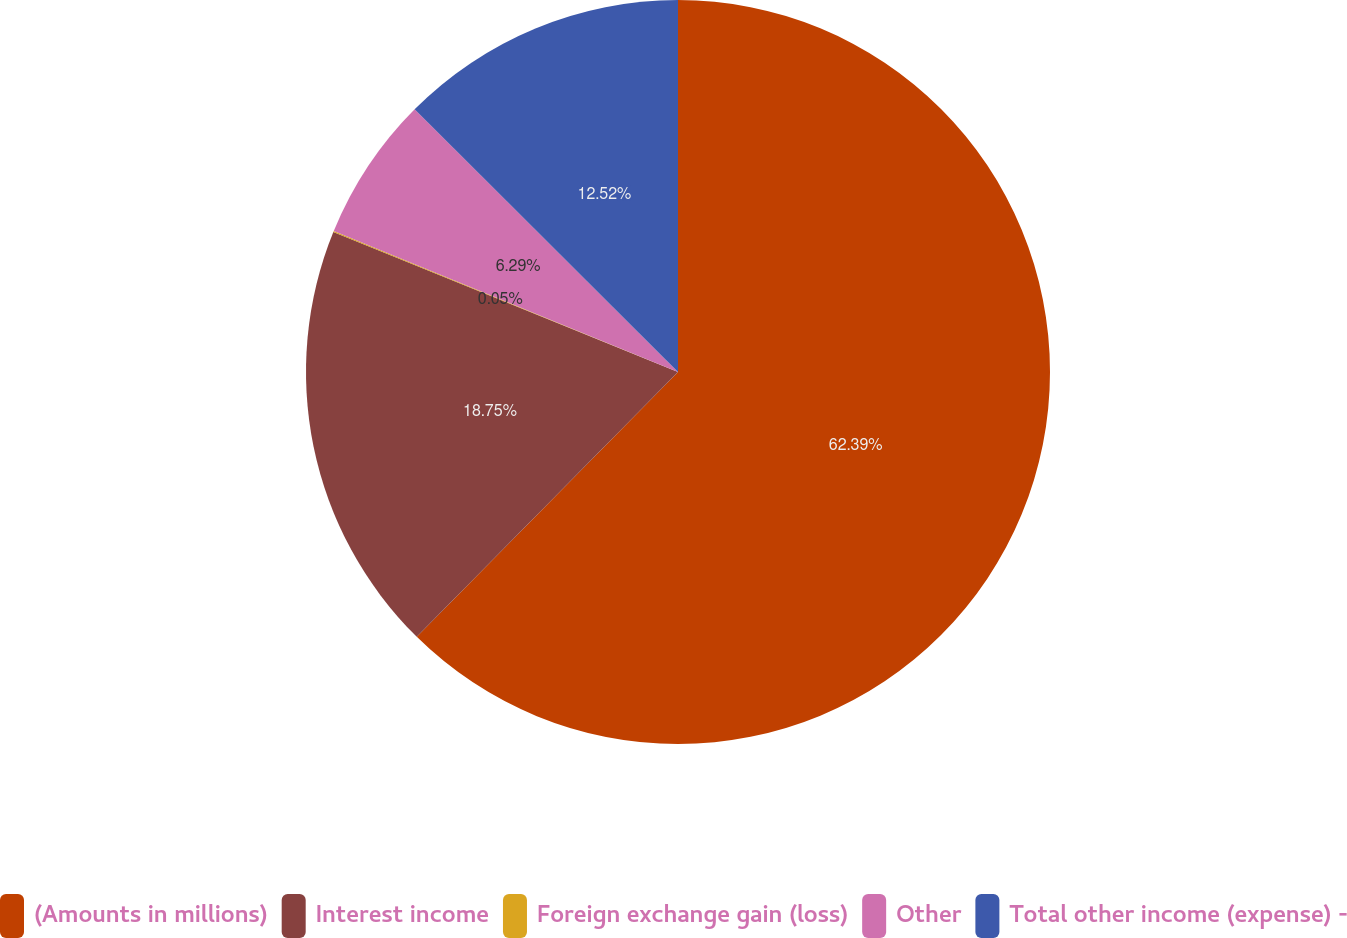Convert chart. <chart><loc_0><loc_0><loc_500><loc_500><pie_chart><fcel>(Amounts in millions)<fcel>Interest income<fcel>Foreign exchange gain (loss)<fcel>Other<fcel>Total other income (expense) -<nl><fcel>62.39%<fcel>18.75%<fcel>0.05%<fcel>6.29%<fcel>12.52%<nl></chart> 